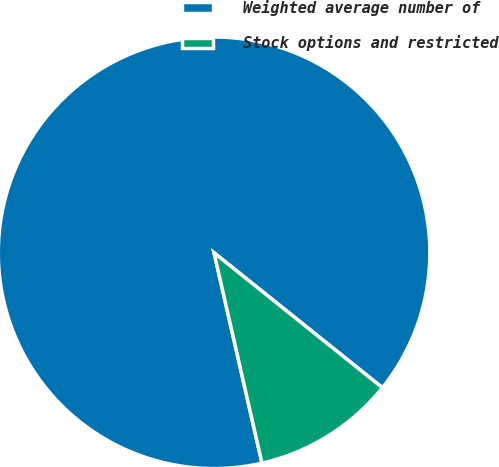<chart> <loc_0><loc_0><loc_500><loc_500><pie_chart><fcel>Weighted average number of<fcel>Stock options and restricted<nl><fcel>89.32%<fcel>10.68%<nl></chart> 